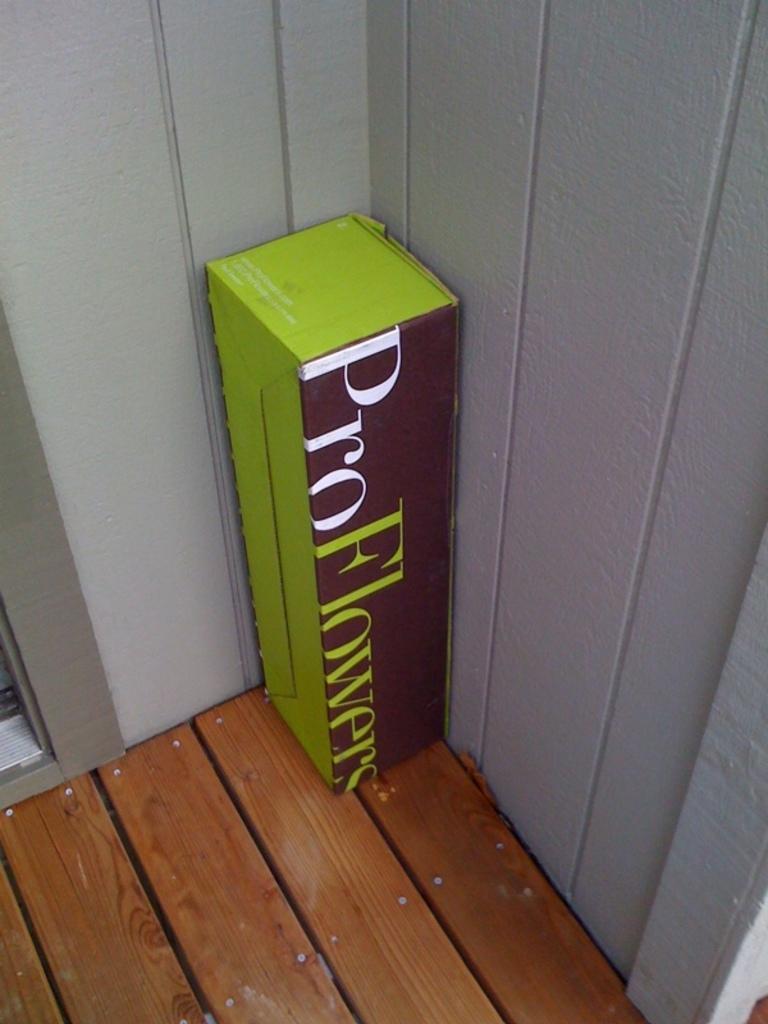What is inside the box?
Ensure brevity in your answer.  Flowers. What company sent this package?
Keep it short and to the point. Pro flowers. 